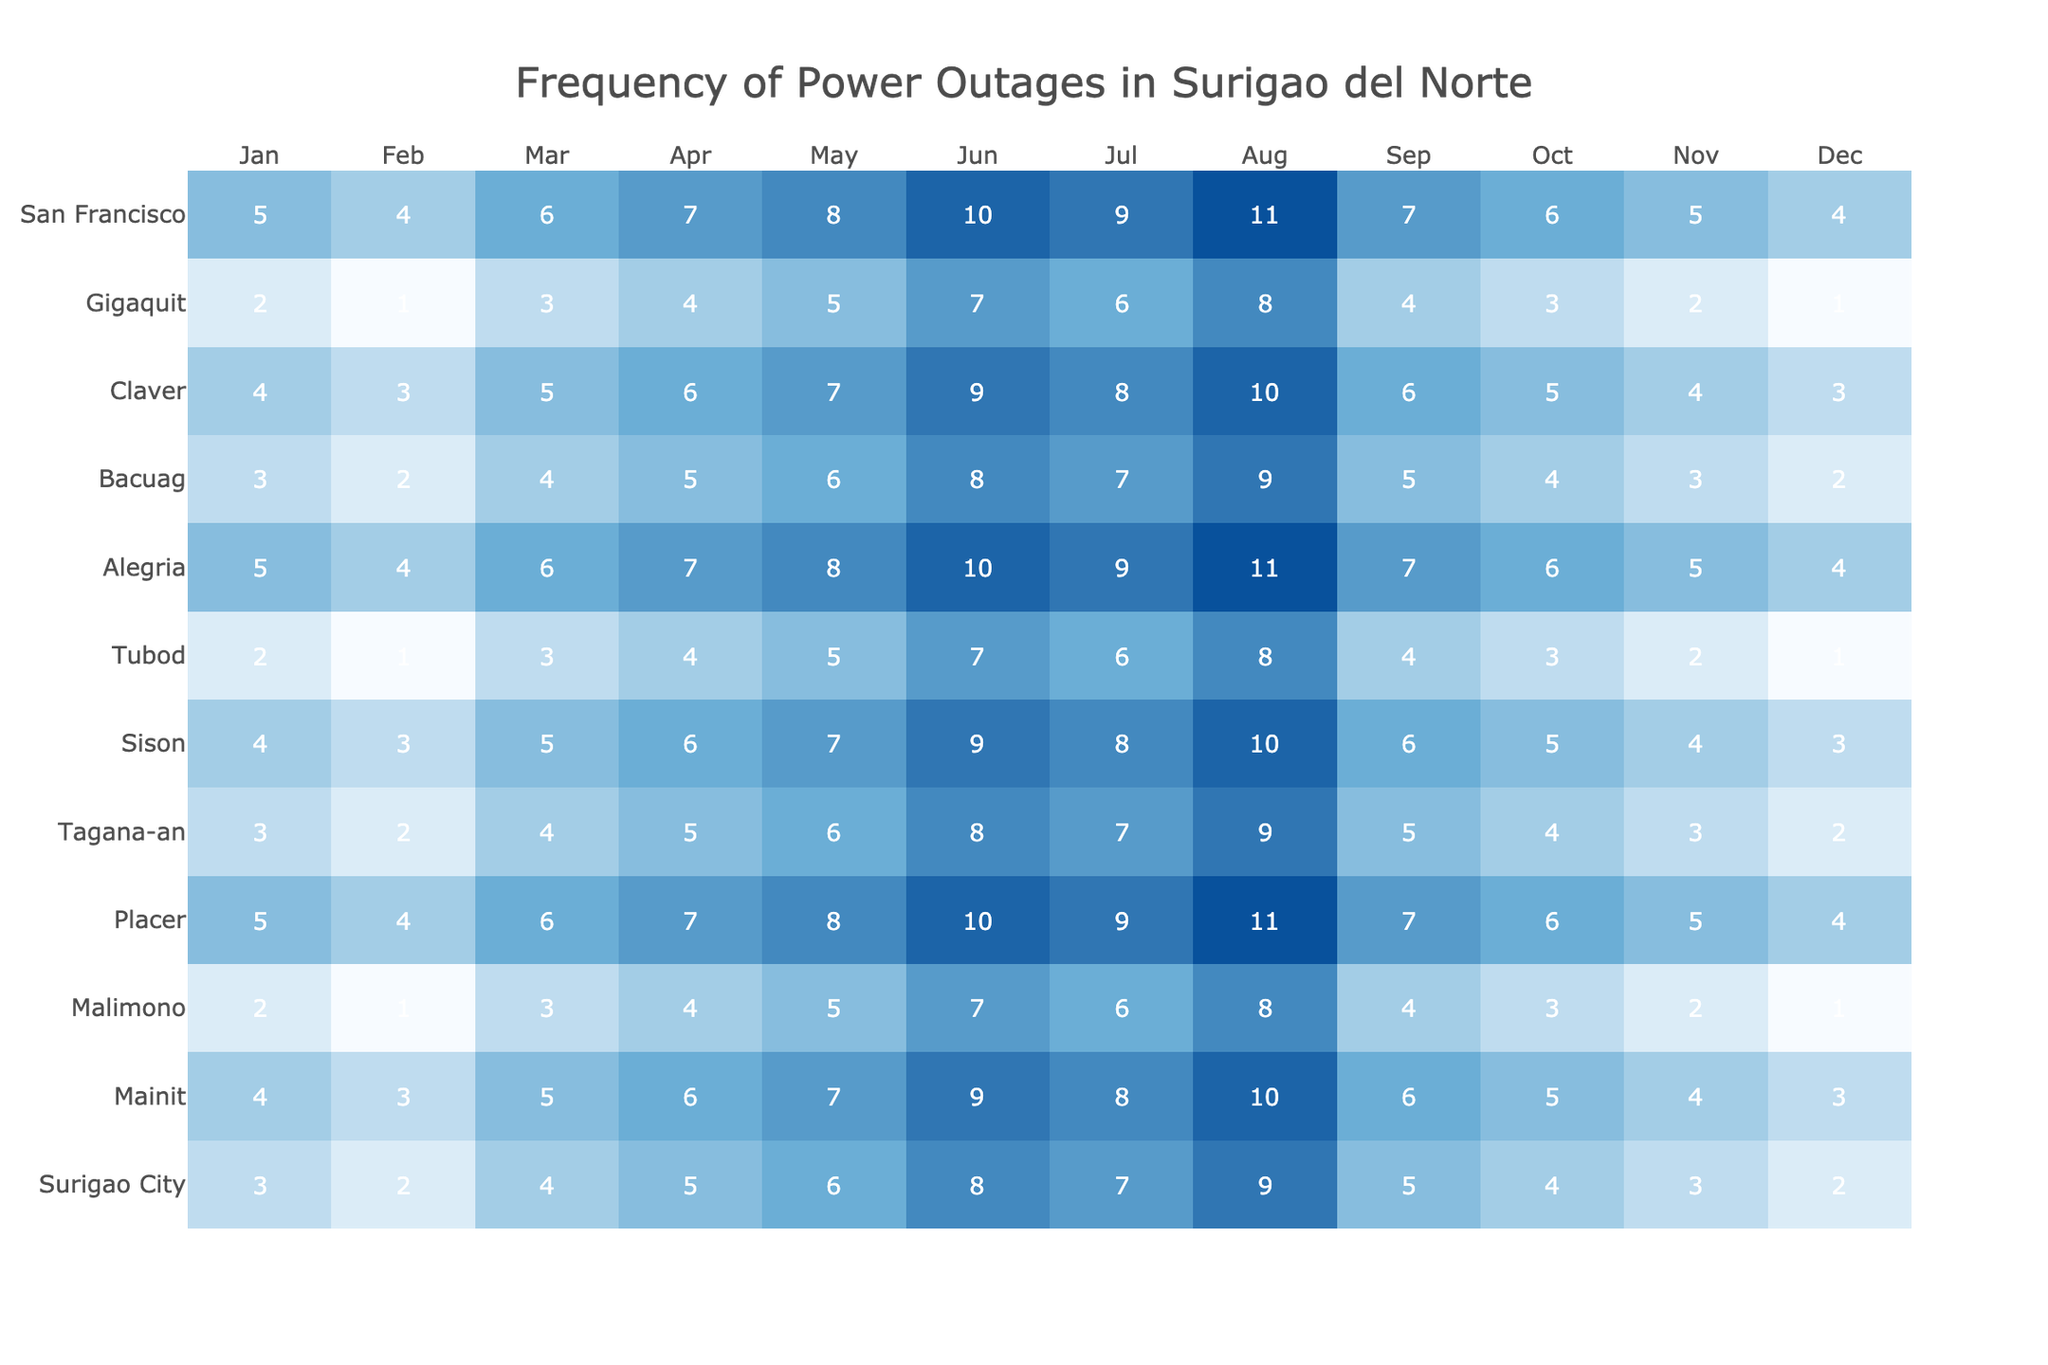What district had the highest frequency of power outages in July? Reviewing the data for each district in July, 'Mainit' had the highest count of 9 power outages.
Answer: Mainit How many total power outages did Surigao City experience in the last 12 months? Adding the outages from each month for Surigao City: 3 + 2 + 4 + 5 + 6 + 8 + 7 + 9 + 5 + 4 + 3 + 2 = 58.
Answer: 58 Which district recorded the least number of power outages during the entire last year? By comparing the total outages across all districts, 'Gigaquit' had the least with a total of 36 outages.
Answer: Gigaquit What was the average number of outages for Placer over the 12 months? To find the average, sum the outages: 5 + 4 + 6 + 7 + 8 + 10 + 9 + 11 + 7 + 6 + 5 + 4 = 77, then divide by 12, giving 77/12 = approximately 6.42.
Answer: Approximately 6.42 Did any district have a consistent increase in power outages each month? Inspecting the monthly data, 'Placer' shows a consistent increase from January to August, confirming a trend of increasing outages.
Answer: Yes What is the difference in the number of power outages between the highest (August) and lowest (January) months for Tagana-an? Evaluating Tagana-an's data, the outages in August (9) minus January (3) equals a difference of 6.
Answer: 6 Which month had the highest total outages across all districts? Summing the outages for each month: January (34), February (27), March (41), April (49), May (58), June (69), July (61), August (76), September (53), October (47), November (38), December (30). August had the highest with 76.
Answer: August For which district did the average outages exceed 8? Calculating the averages: Placer (6.42), Mainit (6.08), Malimono (4.17), Tagana-an (5.25), Sison (6.25), Tubod (4.17), Alegria (7.42), Bacuag (5.25), Claver (6.25), Gigaquit (3.42), and San Francisco (7.92) reveal that no district exceeded 8.
Answer: None In which month did Bacuag have the fewest power outages? Checking Bacuag's numbers, February had the least outages of 2.
Answer: February How many districts had more than 60 outages over the last year? Reviewing the totals, Placer, Mainit, and Alegria each logged more than 60 outages. Therefore, there are three districts.
Answer: Three 